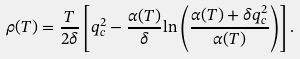Convert formula to latex. <formula><loc_0><loc_0><loc_500><loc_500>\rho ( T ) = \frac { T } { 2 \delta } \left [ { q _ { c } ^ { 2 } } - \frac { \alpha ( T ) } { \delta } { \ln } \left ( \frac { \alpha ( T ) + \delta { q _ { c } ^ { 2 } } } { \alpha ( T ) } \right ) \right ] .</formula> 